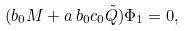Convert formula to latex. <formula><loc_0><loc_0><loc_500><loc_500>( b _ { 0 } M + a \, b _ { 0 } c _ { 0 } \tilde { Q } ) \Phi _ { 1 } = 0 ,</formula> 